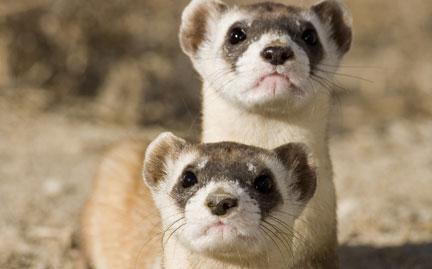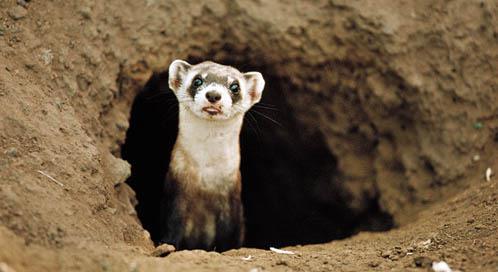The first image is the image on the left, the second image is the image on the right. Analyze the images presented: Is the assertion "In at least one image a Mustelid can be seen sticking its head out of a visible dirt hole." valid? Answer yes or no. Yes. The first image is the image on the left, the second image is the image on the right. For the images shown, is this caption "A ferret is partially inside of a hole." true? Answer yes or no. Yes. 